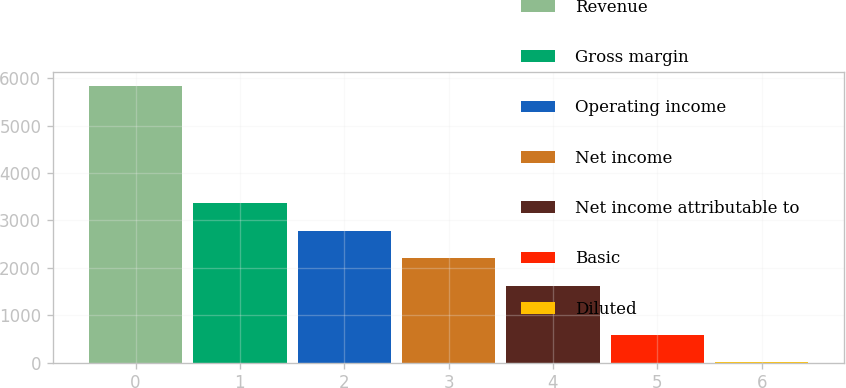Convert chart to OTSL. <chart><loc_0><loc_0><loc_500><loc_500><bar_chart><fcel>Revenue<fcel>Gross margin<fcel>Operating income<fcel>Net income<fcel>Net income attributable to<fcel>Basic<fcel>Diluted<nl><fcel>5835<fcel>3369.08<fcel>2785.72<fcel>2202.36<fcel>1619<fcel>584.78<fcel>1.42<nl></chart> 